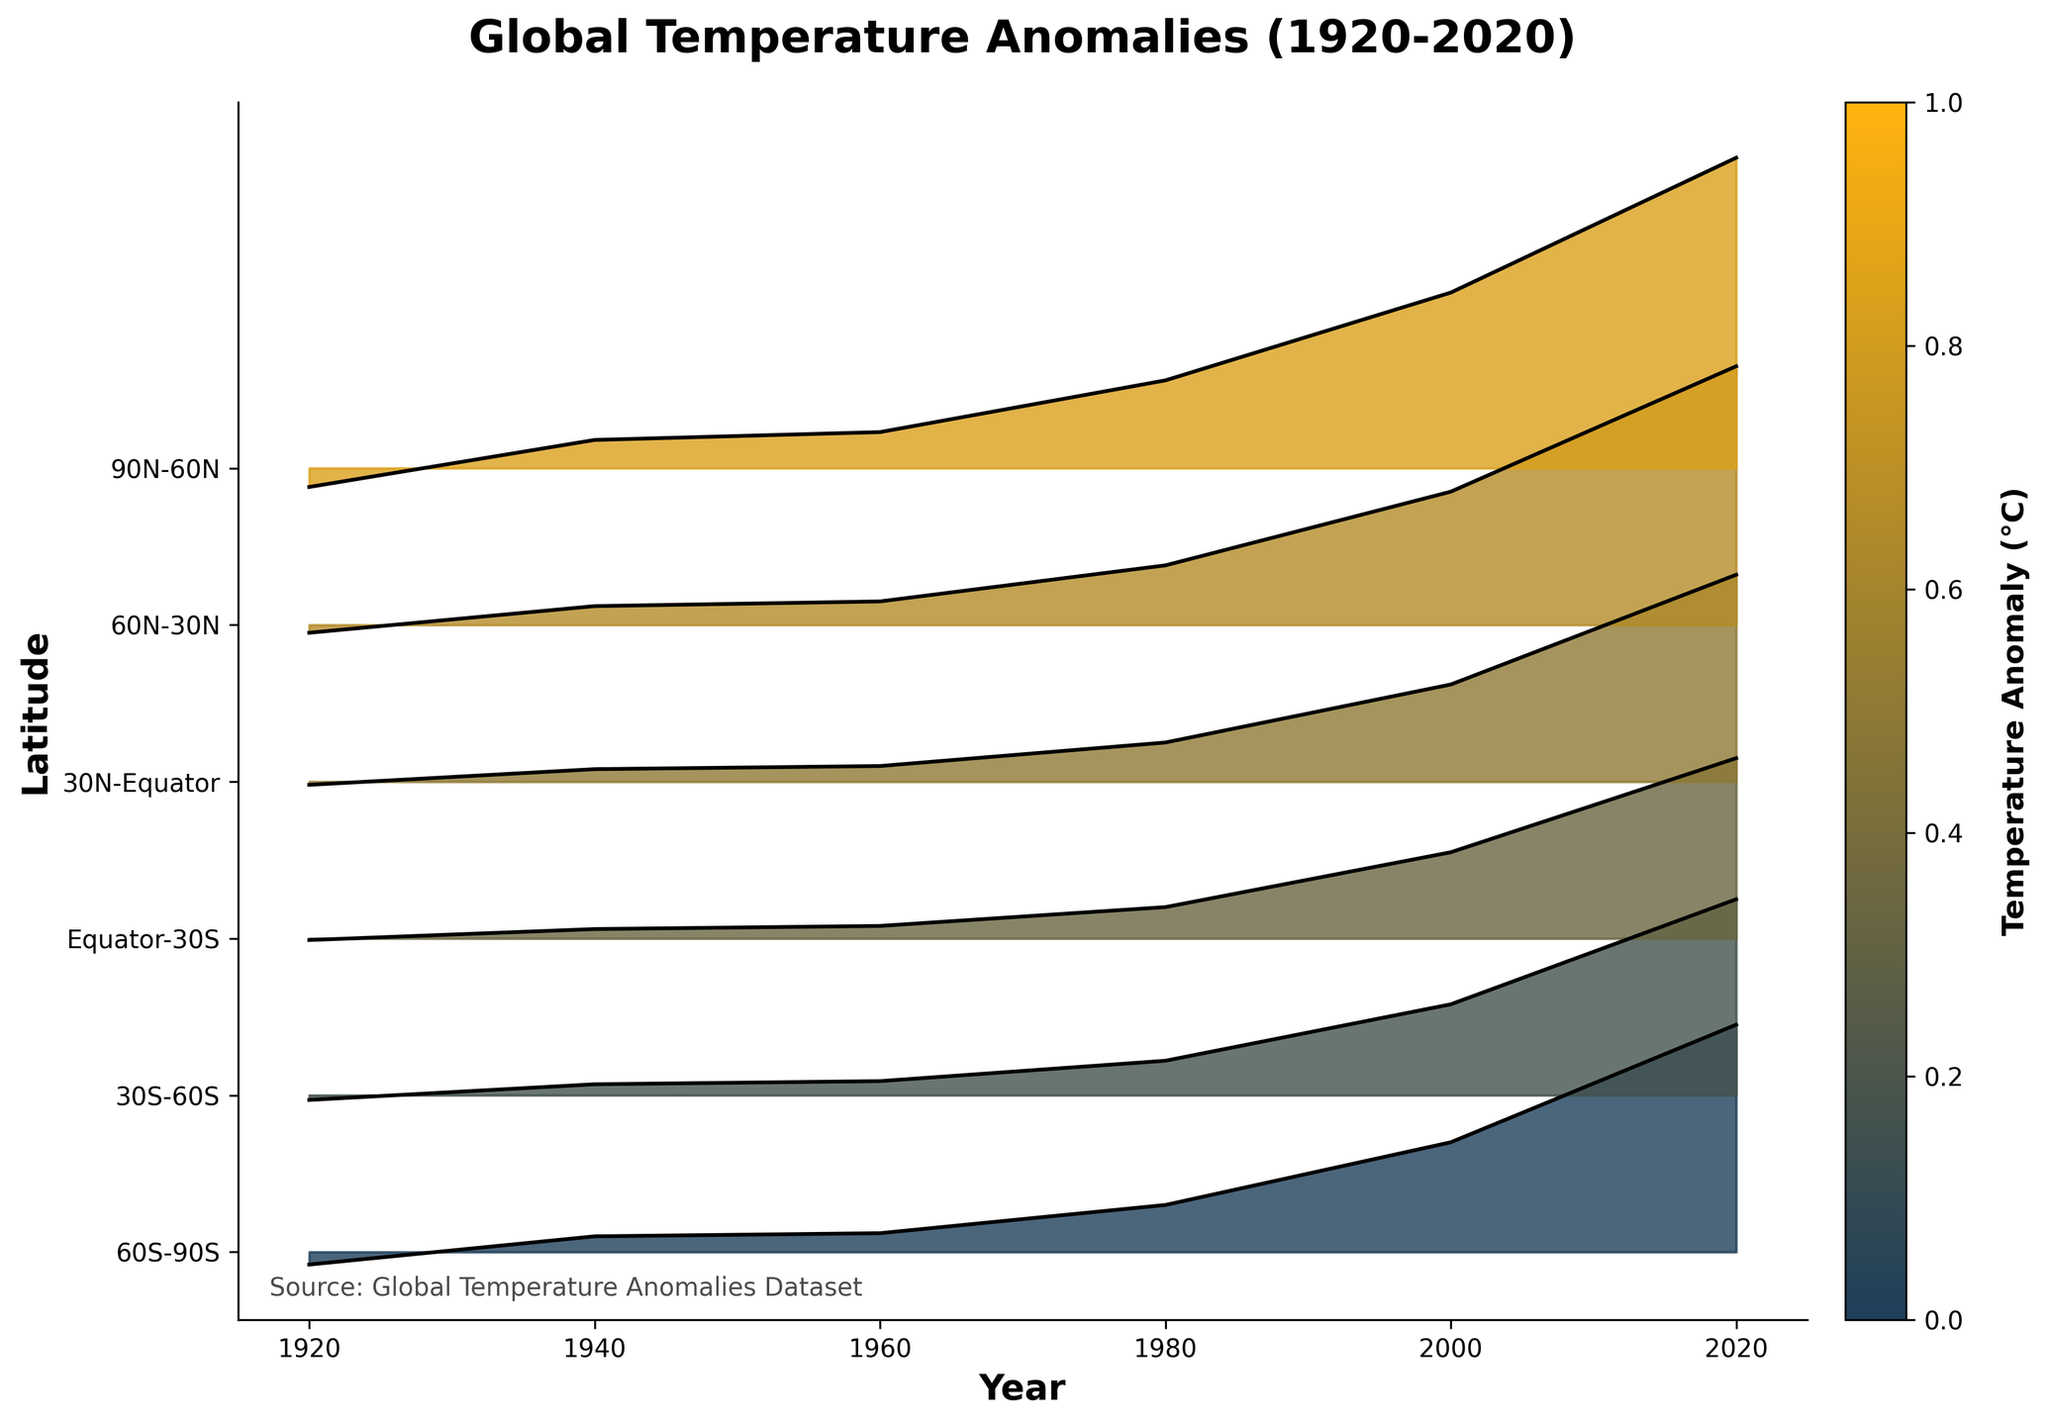What is the title of the plot? The title is usually located at the top of the plot and summarizes what the figure represents.
Answer: Global Temperature Anomalies (1920-2020) Which axis represents the years? In the plot, the x-axis represents the years. The label "Year" below the axis confirms this.
Answer: x-axis How many latitude bands are represented in the plot? By counting the unique tick labels along the y-axis, you see that there are six latitude bands from "90N-60N" to "60S-90S".
Answer: Six What is the temperature anomaly around 2000 for the latitude band 60N-30N? Locate the latitude band "60N-30N" on the y-axis, then find the year 2000 on the x-axis. Read the anomaly value from the plot, which is around 0.85°C.
Answer: 0.85°C Which latitude band shows the highest temperature anomaly in 2020? Find the year 2020 on the x-axis, then compare the anomaly values for all latitude bands. The "90N-60N" band shows the highest value of 1.98°C.
Answer: 90N-60N What is the difference in temperature anomaly between 1920 and 2020 for the latitude band 30N-Equator? For the latitude band "30N-Equator," find the anomaly values for 1920 (-0.02°C) and 2020 (1.32°C). Calculate the difference: 1.32 - (-0.02) = 1.34°C.
Answer: 1.34°C Does any latitude band show a negative anomaly value in 1920? Scan the 1920 column for all latitude bands to see if any values are negative. Both "90N-60N" and "60S-90S" show negative anomalies.
Answer: Yes What is the consistent trend of temperature anomalies from 1920 to 2020 for the Equator-30S latitude band? Observe the line for "Equator-30S" from 1920 to 2020, which shows a steady increase in anomaly values from -0.01°C to 1.15°C.
Answer: Steady increase How do the anomalies in the 90N-60N latitude band for the years 1960 and 2000 compare? Compare the anomaly values in the "90N-60N" band for 1960 (0.23°C) and 2000 (1.12°C). Since 1.12 is greater than 0.23, the anomaly in 2000 is higher than in 1960.
Answer: 2000 is higher Is there any latitude band where the anomalies never exceed 0.20°C until 1960? Review the anomaly values up to 1960 for all latitude bands, noting that "30S-60S" and "Equator-30S" do not exceed 0.20°C during this period.
Answer: Yes 